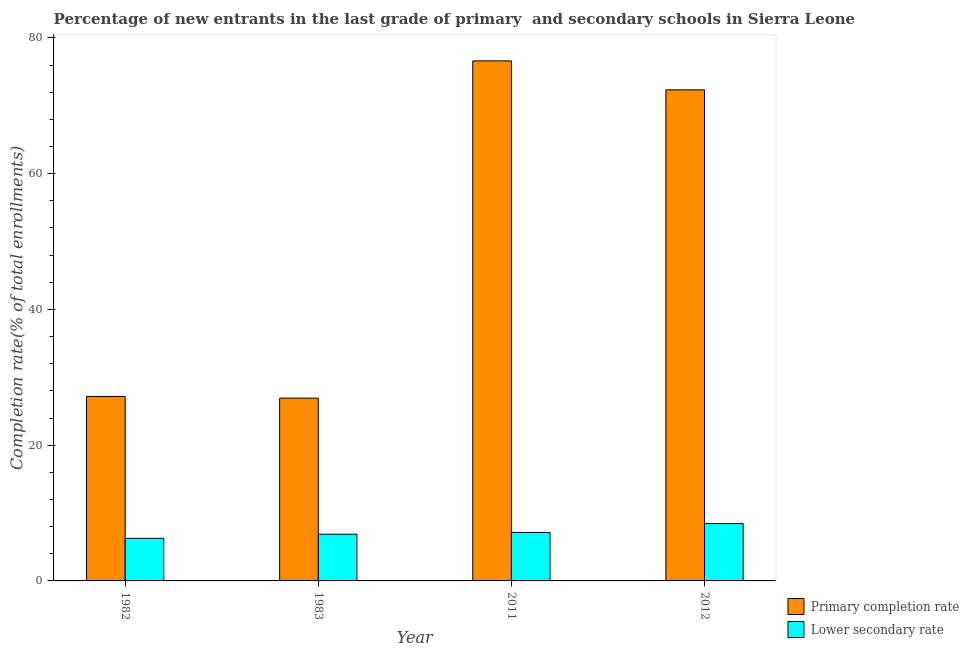How many bars are there on the 1st tick from the left?
Provide a short and direct response. 2. How many bars are there on the 3rd tick from the right?
Make the answer very short. 2. What is the completion rate in primary schools in 2011?
Keep it short and to the point. 76.62. Across all years, what is the maximum completion rate in primary schools?
Give a very brief answer. 76.62. Across all years, what is the minimum completion rate in primary schools?
Your answer should be very brief. 26.93. What is the total completion rate in primary schools in the graph?
Offer a terse response. 203.09. What is the difference between the completion rate in secondary schools in 1982 and that in 1983?
Make the answer very short. -0.6. What is the difference between the completion rate in primary schools in 2012 and the completion rate in secondary schools in 1982?
Provide a succinct answer. 45.17. What is the average completion rate in secondary schools per year?
Provide a short and direct response. 7.19. In the year 1982, what is the difference between the completion rate in secondary schools and completion rate in primary schools?
Your answer should be compact. 0. What is the ratio of the completion rate in secondary schools in 1982 to that in 2012?
Your answer should be compact. 0.74. What is the difference between the highest and the second highest completion rate in primary schools?
Ensure brevity in your answer.  4.27. What is the difference between the highest and the lowest completion rate in primary schools?
Make the answer very short. 49.69. In how many years, is the completion rate in primary schools greater than the average completion rate in primary schools taken over all years?
Keep it short and to the point. 2. Is the sum of the completion rate in secondary schools in 1982 and 2011 greater than the maximum completion rate in primary schools across all years?
Offer a terse response. Yes. What does the 2nd bar from the left in 2012 represents?
Offer a terse response. Lower secondary rate. What does the 2nd bar from the right in 1983 represents?
Provide a short and direct response. Primary completion rate. How many years are there in the graph?
Offer a terse response. 4. What is the difference between two consecutive major ticks on the Y-axis?
Provide a short and direct response. 20. Are the values on the major ticks of Y-axis written in scientific E-notation?
Provide a short and direct response. No. How are the legend labels stacked?
Your answer should be very brief. Vertical. What is the title of the graph?
Give a very brief answer. Percentage of new entrants in the last grade of primary  and secondary schools in Sierra Leone. Does "Researchers" appear as one of the legend labels in the graph?
Ensure brevity in your answer.  No. What is the label or title of the Y-axis?
Provide a succinct answer. Completion rate(% of total enrollments). What is the Completion rate(% of total enrollments) of Primary completion rate in 1982?
Your answer should be very brief. 27.18. What is the Completion rate(% of total enrollments) in Lower secondary rate in 1982?
Your answer should be very brief. 6.28. What is the Completion rate(% of total enrollments) of Primary completion rate in 1983?
Give a very brief answer. 26.93. What is the Completion rate(% of total enrollments) of Lower secondary rate in 1983?
Your answer should be very brief. 6.88. What is the Completion rate(% of total enrollments) of Primary completion rate in 2011?
Provide a succinct answer. 76.62. What is the Completion rate(% of total enrollments) of Lower secondary rate in 2011?
Your answer should be very brief. 7.15. What is the Completion rate(% of total enrollments) of Primary completion rate in 2012?
Your answer should be compact. 72.36. What is the Completion rate(% of total enrollments) in Lower secondary rate in 2012?
Make the answer very short. 8.45. Across all years, what is the maximum Completion rate(% of total enrollments) in Primary completion rate?
Offer a terse response. 76.62. Across all years, what is the maximum Completion rate(% of total enrollments) in Lower secondary rate?
Offer a very short reply. 8.45. Across all years, what is the minimum Completion rate(% of total enrollments) of Primary completion rate?
Your response must be concise. 26.93. Across all years, what is the minimum Completion rate(% of total enrollments) in Lower secondary rate?
Your answer should be compact. 6.28. What is the total Completion rate(% of total enrollments) of Primary completion rate in the graph?
Provide a succinct answer. 203.09. What is the total Completion rate(% of total enrollments) of Lower secondary rate in the graph?
Ensure brevity in your answer.  28.76. What is the difference between the Completion rate(% of total enrollments) of Primary completion rate in 1982 and that in 1983?
Make the answer very short. 0.26. What is the difference between the Completion rate(% of total enrollments) of Lower secondary rate in 1982 and that in 1983?
Make the answer very short. -0.6. What is the difference between the Completion rate(% of total enrollments) in Primary completion rate in 1982 and that in 2011?
Ensure brevity in your answer.  -49.44. What is the difference between the Completion rate(% of total enrollments) in Lower secondary rate in 1982 and that in 2011?
Make the answer very short. -0.87. What is the difference between the Completion rate(% of total enrollments) of Primary completion rate in 1982 and that in 2012?
Give a very brief answer. -45.17. What is the difference between the Completion rate(% of total enrollments) in Lower secondary rate in 1982 and that in 2012?
Ensure brevity in your answer.  -2.17. What is the difference between the Completion rate(% of total enrollments) in Primary completion rate in 1983 and that in 2011?
Your answer should be very brief. -49.69. What is the difference between the Completion rate(% of total enrollments) of Lower secondary rate in 1983 and that in 2011?
Keep it short and to the point. -0.27. What is the difference between the Completion rate(% of total enrollments) of Primary completion rate in 1983 and that in 2012?
Give a very brief answer. -45.43. What is the difference between the Completion rate(% of total enrollments) of Lower secondary rate in 1983 and that in 2012?
Offer a very short reply. -1.57. What is the difference between the Completion rate(% of total enrollments) in Primary completion rate in 2011 and that in 2012?
Your response must be concise. 4.27. What is the difference between the Completion rate(% of total enrollments) in Lower secondary rate in 2011 and that in 2012?
Provide a short and direct response. -1.31. What is the difference between the Completion rate(% of total enrollments) of Primary completion rate in 1982 and the Completion rate(% of total enrollments) of Lower secondary rate in 1983?
Ensure brevity in your answer.  20.3. What is the difference between the Completion rate(% of total enrollments) in Primary completion rate in 1982 and the Completion rate(% of total enrollments) in Lower secondary rate in 2011?
Make the answer very short. 20.04. What is the difference between the Completion rate(% of total enrollments) in Primary completion rate in 1982 and the Completion rate(% of total enrollments) in Lower secondary rate in 2012?
Provide a succinct answer. 18.73. What is the difference between the Completion rate(% of total enrollments) in Primary completion rate in 1983 and the Completion rate(% of total enrollments) in Lower secondary rate in 2011?
Keep it short and to the point. 19.78. What is the difference between the Completion rate(% of total enrollments) of Primary completion rate in 1983 and the Completion rate(% of total enrollments) of Lower secondary rate in 2012?
Offer a very short reply. 18.48. What is the difference between the Completion rate(% of total enrollments) of Primary completion rate in 2011 and the Completion rate(% of total enrollments) of Lower secondary rate in 2012?
Provide a succinct answer. 68.17. What is the average Completion rate(% of total enrollments) of Primary completion rate per year?
Your answer should be compact. 50.77. What is the average Completion rate(% of total enrollments) of Lower secondary rate per year?
Keep it short and to the point. 7.19. In the year 1982, what is the difference between the Completion rate(% of total enrollments) in Primary completion rate and Completion rate(% of total enrollments) in Lower secondary rate?
Offer a very short reply. 20.91. In the year 1983, what is the difference between the Completion rate(% of total enrollments) in Primary completion rate and Completion rate(% of total enrollments) in Lower secondary rate?
Offer a very short reply. 20.05. In the year 2011, what is the difference between the Completion rate(% of total enrollments) in Primary completion rate and Completion rate(% of total enrollments) in Lower secondary rate?
Your answer should be very brief. 69.48. In the year 2012, what is the difference between the Completion rate(% of total enrollments) in Primary completion rate and Completion rate(% of total enrollments) in Lower secondary rate?
Keep it short and to the point. 63.9. What is the ratio of the Completion rate(% of total enrollments) of Primary completion rate in 1982 to that in 1983?
Your answer should be compact. 1.01. What is the ratio of the Completion rate(% of total enrollments) of Lower secondary rate in 1982 to that in 1983?
Keep it short and to the point. 0.91. What is the ratio of the Completion rate(% of total enrollments) in Primary completion rate in 1982 to that in 2011?
Offer a terse response. 0.35. What is the ratio of the Completion rate(% of total enrollments) of Lower secondary rate in 1982 to that in 2011?
Keep it short and to the point. 0.88. What is the ratio of the Completion rate(% of total enrollments) in Primary completion rate in 1982 to that in 2012?
Give a very brief answer. 0.38. What is the ratio of the Completion rate(% of total enrollments) of Lower secondary rate in 1982 to that in 2012?
Your answer should be very brief. 0.74. What is the ratio of the Completion rate(% of total enrollments) in Primary completion rate in 1983 to that in 2011?
Offer a terse response. 0.35. What is the ratio of the Completion rate(% of total enrollments) in Lower secondary rate in 1983 to that in 2011?
Make the answer very short. 0.96. What is the ratio of the Completion rate(% of total enrollments) of Primary completion rate in 1983 to that in 2012?
Your answer should be compact. 0.37. What is the ratio of the Completion rate(% of total enrollments) of Lower secondary rate in 1983 to that in 2012?
Your response must be concise. 0.81. What is the ratio of the Completion rate(% of total enrollments) of Primary completion rate in 2011 to that in 2012?
Make the answer very short. 1.06. What is the ratio of the Completion rate(% of total enrollments) of Lower secondary rate in 2011 to that in 2012?
Provide a succinct answer. 0.85. What is the difference between the highest and the second highest Completion rate(% of total enrollments) in Primary completion rate?
Provide a succinct answer. 4.27. What is the difference between the highest and the second highest Completion rate(% of total enrollments) of Lower secondary rate?
Your answer should be very brief. 1.31. What is the difference between the highest and the lowest Completion rate(% of total enrollments) in Primary completion rate?
Ensure brevity in your answer.  49.69. What is the difference between the highest and the lowest Completion rate(% of total enrollments) in Lower secondary rate?
Your answer should be very brief. 2.17. 